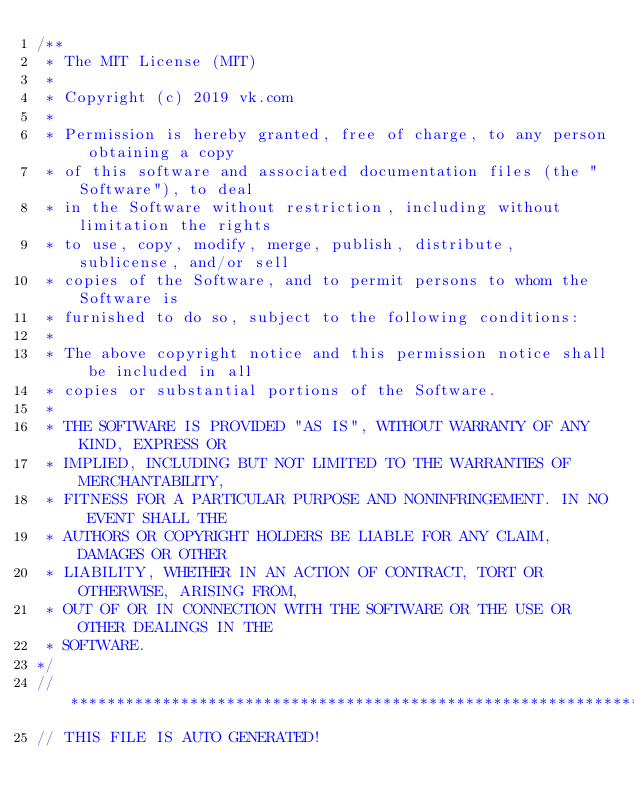<code> <loc_0><loc_0><loc_500><loc_500><_Kotlin_>/**
 * The MIT License (MIT)
 *
 * Copyright (c) 2019 vk.com
 *
 * Permission is hereby granted, free of charge, to any person obtaining a copy
 * of this software and associated documentation files (the "Software"), to deal
 * in the Software without restriction, including without limitation the rights
 * to use, copy, modify, merge, publish, distribute, sublicense, and/or sell
 * copies of the Software, and to permit persons to whom the Software is
 * furnished to do so, subject to the following conditions:
 *
 * The above copyright notice and this permission notice shall be included in all
 * copies or substantial portions of the Software.
 *
 * THE SOFTWARE IS PROVIDED "AS IS", WITHOUT WARRANTY OF ANY KIND, EXPRESS OR
 * IMPLIED, INCLUDING BUT NOT LIMITED TO THE WARRANTIES OF MERCHANTABILITY,
 * FITNESS FOR A PARTICULAR PURPOSE AND NONINFRINGEMENT. IN NO EVENT SHALL THE
 * AUTHORS OR COPYRIGHT HOLDERS BE LIABLE FOR ANY CLAIM, DAMAGES OR OTHER
 * LIABILITY, WHETHER IN AN ACTION OF CONTRACT, TORT OR OTHERWISE, ARISING FROM,
 * OUT OF OR IN CONNECTION WITH THE SOFTWARE OR THE USE OR OTHER DEALINGS IN THE
 * SOFTWARE.
*/
// *********************************************************************
// THIS FILE IS AUTO GENERATED!</code> 